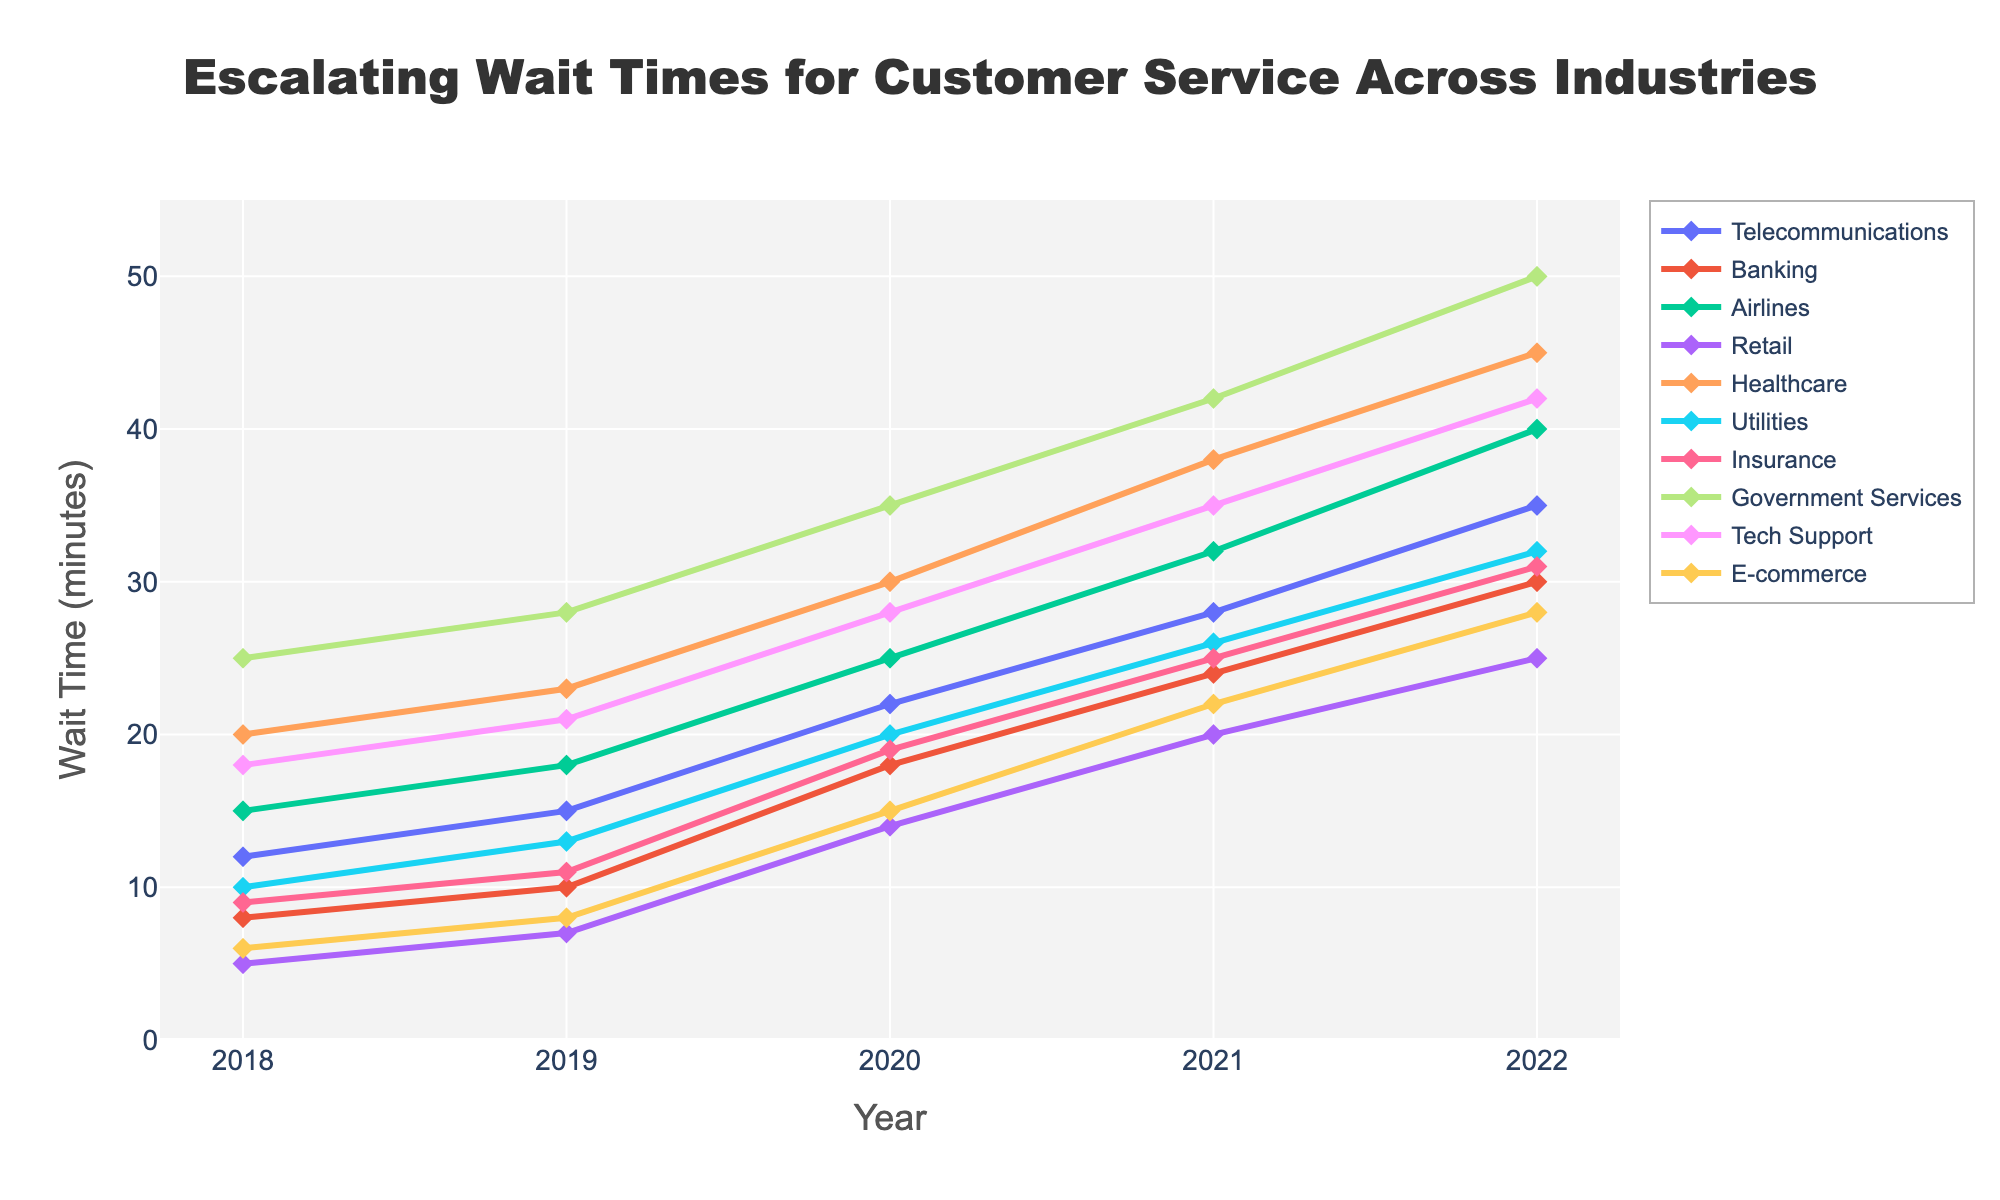What industry had the highest wait time in 2022? Looking at the line chart for the year 2022, the highest data point is for Government Services.
Answer: Government Services Which industry had the smallest increase in wait times from 2018 to 2022? To find the smallest increase, subtract the 2018 wait time from the 2022 wait time for each industry. The industry with the smallest difference is Retail (25 - 5 = 20 minutes).
Answer: Retail What is the difference in wait times between Airlines and Telecommunications in 2021? Check the 2021 data points for Airlines (32 minutes) and Telecommunications (28 minutes), then subtract 28 from 32.
Answer: 4 minutes Compare the trend lines for Healthcare and Tech Support. Which industry exhibited a steeper increase in wait times from 2018 to 2022? To determine the steeper increase, calculate the difference between 2022 and 2018 wait times for both industries. Healthcare increased by 25 minutes (45 - 20), while Tech Support increased by 24 minutes (42 - 18). Therefore, Healthcare's increase was steeper.
Answer: Healthcare How does the wait time for E-commerce in 2022 compare to the Bank wait time in 2020? Check the E-commerce wait time in 2022 (28 minutes) and compare it to the Banking wait time in 2020 (18 minutes). E-commerce in 2022 is greater by 10 minutes.
Answer: 10 minutes What was the average wait time for Government Services from 2018 to 2022? Sum the Government Services wait times for each year (25 + 28 + 35 + 42 + 50) and divide by the number of years (5). (25+28+35+42+50=180, 180/5 = 36).
Answer: 36 minutes Which year showed the most considerable increase in wait times across all industries? By visually comparing year-to-year changes, the jump from 2019 to 2020 shows the most significant increase across multiple industries.
Answer: 2019 to 2020 Which two industries had nearly parallel trend lines? Looking at the slopes of the lines, Banking and Insurance appear almost parallel to each other across the years.
Answer: Banking and Insurance What is the total increase in wait times for the Retail industry from 2018 to 2022? Subtract the wait time in 2018 (5 minutes) from the wait time in 2022 (25 minutes) for Retail.
Answer: 20 minutes Which industry has the second-highest wait time in 2022? Based on a visual inspection of the 2022 data points, Healthcare has the second-highest wait time after Government Services.
Answer: Healthcare 